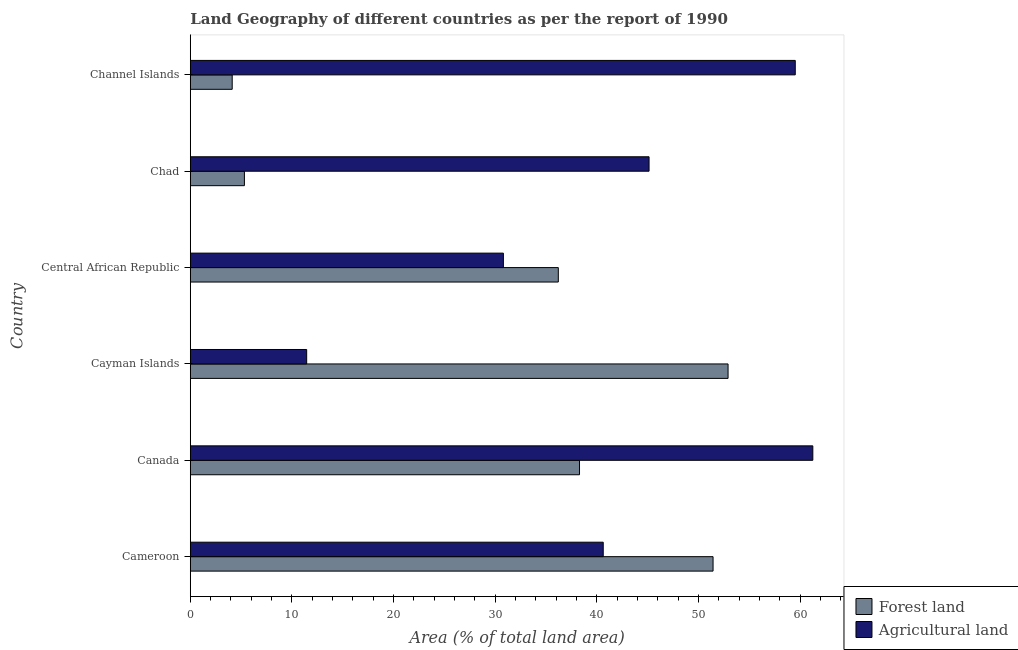How many different coloured bars are there?
Make the answer very short. 2. How many groups of bars are there?
Give a very brief answer. 6. How many bars are there on the 4th tick from the bottom?
Give a very brief answer. 2. What is the label of the 6th group of bars from the top?
Your answer should be compact. Cameroon. In how many cases, is the number of bars for a given country not equal to the number of legend labels?
Your answer should be very brief. 0. What is the percentage of land area under agriculture in Central African Republic?
Keep it short and to the point. 30.81. Across all countries, what is the maximum percentage of land area under agriculture?
Make the answer very short. 61.26. Across all countries, what is the minimum percentage of land area under forests?
Provide a short and direct response. 4.12. In which country was the percentage of land area under agriculture minimum?
Offer a terse response. Cayman Islands. What is the total percentage of land area under agriculture in the graph?
Provide a succinct answer. 248.82. What is the difference between the percentage of land area under forests in Cameroon and that in Central African Republic?
Give a very brief answer. 15.23. What is the difference between the percentage of land area under agriculture in Canada and the percentage of land area under forests in Chad?
Ensure brevity in your answer.  55.93. What is the average percentage of land area under forests per country?
Keep it short and to the point. 31.39. What is the difference between the percentage of land area under agriculture and percentage of land area under forests in Channel Islands?
Give a very brief answer. 55.41. In how many countries, is the percentage of land area under agriculture greater than 28 %?
Your answer should be compact. 5. What is the ratio of the percentage of land area under agriculture in Cameroon to that in Channel Islands?
Ensure brevity in your answer.  0.68. Is the percentage of land area under agriculture in Cameroon less than that in Central African Republic?
Offer a very short reply. No. Is the difference between the percentage of land area under forests in Cameroon and Channel Islands greater than the difference between the percentage of land area under agriculture in Cameroon and Channel Islands?
Make the answer very short. Yes. What is the difference between the highest and the second highest percentage of land area under agriculture?
Your answer should be compact. 1.73. What is the difference between the highest and the lowest percentage of land area under agriculture?
Your answer should be very brief. 49.81. In how many countries, is the percentage of land area under forests greater than the average percentage of land area under forests taken over all countries?
Your answer should be very brief. 4. What does the 2nd bar from the top in Canada represents?
Give a very brief answer. Forest land. What does the 2nd bar from the bottom in Channel Islands represents?
Your response must be concise. Agricultural land. How many bars are there?
Offer a very short reply. 12. How many countries are there in the graph?
Your response must be concise. 6. Where does the legend appear in the graph?
Offer a terse response. Bottom right. What is the title of the graph?
Your answer should be compact. Land Geography of different countries as per the report of 1990. What is the label or title of the X-axis?
Keep it short and to the point. Area (% of total land area). What is the Area (% of total land area) in Forest land in Cameroon?
Your answer should be very brief. 51.44. What is the Area (% of total land area) of Agricultural land in Cameroon?
Offer a very short reply. 40.63. What is the Area (% of total land area) of Forest land in Canada?
Ensure brevity in your answer.  38.3. What is the Area (% of total land area) of Agricultural land in Canada?
Provide a short and direct response. 61.26. What is the Area (% of total land area) of Forest land in Cayman Islands?
Ensure brevity in your answer.  52.92. What is the Area (% of total land area) of Agricultural land in Cayman Islands?
Offer a very short reply. 11.45. What is the Area (% of total land area) in Forest land in Central African Republic?
Offer a terse response. 36.21. What is the Area (% of total land area) in Agricultural land in Central African Republic?
Keep it short and to the point. 30.81. What is the Area (% of total land area) in Forest land in Chad?
Offer a terse response. 5.32. What is the Area (% of total land area) in Agricultural land in Chad?
Make the answer very short. 45.14. What is the Area (% of total land area) in Forest land in Channel Islands?
Give a very brief answer. 4.12. What is the Area (% of total land area) in Agricultural land in Channel Islands?
Ensure brevity in your answer.  59.53. Across all countries, what is the maximum Area (% of total land area) of Forest land?
Keep it short and to the point. 52.92. Across all countries, what is the maximum Area (% of total land area) in Agricultural land?
Offer a terse response. 61.26. Across all countries, what is the minimum Area (% of total land area) in Forest land?
Keep it short and to the point. 4.12. Across all countries, what is the minimum Area (% of total land area) of Agricultural land?
Make the answer very short. 11.45. What is the total Area (% of total land area) of Forest land in the graph?
Your answer should be very brief. 188.32. What is the total Area (% of total land area) in Agricultural land in the graph?
Make the answer very short. 248.82. What is the difference between the Area (% of total land area) in Forest land in Cameroon and that in Canada?
Offer a very short reply. 13.14. What is the difference between the Area (% of total land area) of Agricultural land in Cameroon and that in Canada?
Make the answer very short. -20.62. What is the difference between the Area (% of total land area) in Forest land in Cameroon and that in Cayman Islands?
Make the answer very short. -1.48. What is the difference between the Area (% of total land area) of Agricultural land in Cameroon and that in Cayman Islands?
Provide a succinct answer. 29.18. What is the difference between the Area (% of total land area) of Forest land in Cameroon and that in Central African Republic?
Provide a succinct answer. 15.23. What is the difference between the Area (% of total land area) in Agricultural land in Cameroon and that in Central African Republic?
Provide a short and direct response. 9.83. What is the difference between the Area (% of total land area) in Forest land in Cameroon and that in Chad?
Offer a very short reply. 46.11. What is the difference between the Area (% of total land area) of Agricultural land in Cameroon and that in Chad?
Offer a very short reply. -4.51. What is the difference between the Area (% of total land area) of Forest land in Cameroon and that in Channel Islands?
Your answer should be compact. 47.32. What is the difference between the Area (% of total land area) of Agricultural land in Cameroon and that in Channel Islands?
Keep it short and to the point. -18.89. What is the difference between the Area (% of total land area) in Forest land in Canada and that in Cayman Islands?
Your answer should be compact. -14.62. What is the difference between the Area (% of total land area) of Agricultural land in Canada and that in Cayman Islands?
Your response must be concise. 49.81. What is the difference between the Area (% of total land area) in Forest land in Canada and that in Central African Republic?
Your response must be concise. 2.09. What is the difference between the Area (% of total land area) in Agricultural land in Canada and that in Central African Republic?
Your answer should be very brief. 30.45. What is the difference between the Area (% of total land area) of Forest land in Canada and that in Chad?
Ensure brevity in your answer.  32.97. What is the difference between the Area (% of total land area) of Agricultural land in Canada and that in Chad?
Give a very brief answer. 16.11. What is the difference between the Area (% of total land area) in Forest land in Canada and that in Channel Islands?
Give a very brief answer. 34.18. What is the difference between the Area (% of total land area) in Agricultural land in Canada and that in Channel Islands?
Ensure brevity in your answer.  1.73. What is the difference between the Area (% of total land area) in Forest land in Cayman Islands and that in Central African Republic?
Make the answer very short. 16.7. What is the difference between the Area (% of total land area) in Agricultural land in Cayman Islands and that in Central African Republic?
Provide a succinct answer. -19.36. What is the difference between the Area (% of total land area) of Forest land in Cayman Islands and that in Chad?
Your answer should be compact. 47.59. What is the difference between the Area (% of total land area) in Agricultural land in Cayman Islands and that in Chad?
Provide a succinct answer. -33.69. What is the difference between the Area (% of total land area) of Forest land in Cayman Islands and that in Channel Islands?
Offer a very short reply. 48.79. What is the difference between the Area (% of total land area) of Agricultural land in Cayman Islands and that in Channel Islands?
Provide a succinct answer. -48.08. What is the difference between the Area (% of total land area) of Forest land in Central African Republic and that in Chad?
Provide a short and direct response. 30.89. What is the difference between the Area (% of total land area) of Agricultural land in Central African Republic and that in Chad?
Offer a very short reply. -14.33. What is the difference between the Area (% of total land area) of Forest land in Central African Republic and that in Channel Islands?
Provide a short and direct response. 32.09. What is the difference between the Area (% of total land area) of Agricultural land in Central African Republic and that in Channel Islands?
Offer a terse response. -28.72. What is the difference between the Area (% of total land area) of Forest land in Chad and that in Channel Islands?
Keep it short and to the point. 1.2. What is the difference between the Area (% of total land area) of Agricultural land in Chad and that in Channel Islands?
Give a very brief answer. -14.39. What is the difference between the Area (% of total land area) in Forest land in Cameroon and the Area (% of total land area) in Agricultural land in Canada?
Your answer should be compact. -9.82. What is the difference between the Area (% of total land area) of Forest land in Cameroon and the Area (% of total land area) of Agricultural land in Cayman Islands?
Make the answer very short. 39.99. What is the difference between the Area (% of total land area) in Forest land in Cameroon and the Area (% of total land area) in Agricultural land in Central African Republic?
Your response must be concise. 20.63. What is the difference between the Area (% of total land area) of Forest land in Cameroon and the Area (% of total land area) of Agricultural land in Chad?
Provide a short and direct response. 6.3. What is the difference between the Area (% of total land area) of Forest land in Cameroon and the Area (% of total land area) of Agricultural land in Channel Islands?
Your answer should be compact. -8.09. What is the difference between the Area (% of total land area) of Forest land in Canada and the Area (% of total land area) of Agricultural land in Cayman Islands?
Offer a very short reply. 26.85. What is the difference between the Area (% of total land area) of Forest land in Canada and the Area (% of total land area) of Agricultural land in Central African Republic?
Offer a very short reply. 7.49. What is the difference between the Area (% of total land area) of Forest land in Canada and the Area (% of total land area) of Agricultural land in Chad?
Keep it short and to the point. -6.84. What is the difference between the Area (% of total land area) in Forest land in Canada and the Area (% of total land area) in Agricultural land in Channel Islands?
Provide a short and direct response. -21.23. What is the difference between the Area (% of total land area) of Forest land in Cayman Islands and the Area (% of total land area) of Agricultural land in Central African Republic?
Your answer should be compact. 22.11. What is the difference between the Area (% of total land area) in Forest land in Cayman Islands and the Area (% of total land area) in Agricultural land in Chad?
Your answer should be compact. 7.77. What is the difference between the Area (% of total land area) of Forest land in Cayman Islands and the Area (% of total land area) of Agricultural land in Channel Islands?
Your response must be concise. -6.61. What is the difference between the Area (% of total land area) of Forest land in Central African Republic and the Area (% of total land area) of Agricultural land in Chad?
Keep it short and to the point. -8.93. What is the difference between the Area (% of total land area) of Forest land in Central African Republic and the Area (% of total land area) of Agricultural land in Channel Islands?
Provide a succinct answer. -23.32. What is the difference between the Area (% of total land area) of Forest land in Chad and the Area (% of total land area) of Agricultural land in Channel Islands?
Offer a terse response. -54.2. What is the average Area (% of total land area) of Forest land per country?
Make the answer very short. 31.39. What is the average Area (% of total land area) in Agricultural land per country?
Make the answer very short. 41.47. What is the difference between the Area (% of total land area) in Forest land and Area (% of total land area) in Agricultural land in Cameroon?
Offer a very short reply. 10.81. What is the difference between the Area (% of total land area) in Forest land and Area (% of total land area) in Agricultural land in Canada?
Offer a terse response. -22.96. What is the difference between the Area (% of total land area) in Forest land and Area (% of total land area) in Agricultural land in Cayman Islands?
Offer a very short reply. 41.47. What is the difference between the Area (% of total land area) of Forest land and Area (% of total land area) of Agricultural land in Central African Republic?
Keep it short and to the point. 5.4. What is the difference between the Area (% of total land area) of Forest land and Area (% of total land area) of Agricultural land in Chad?
Offer a terse response. -39.82. What is the difference between the Area (% of total land area) in Forest land and Area (% of total land area) in Agricultural land in Channel Islands?
Ensure brevity in your answer.  -55.4. What is the ratio of the Area (% of total land area) of Forest land in Cameroon to that in Canada?
Make the answer very short. 1.34. What is the ratio of the Area (% of total land area) of Agricultural land in Cameroon to that in Canada?
Keep it short and to the point. 0.66. What is the ratio of the Area (% of total land area) of Forest land in Cameroon to that in Cayman Islands?
Your answer should be compact. 0.97. What is the ratio of the Area (% of total land area) in Agricultural land in Cameroon to that in Cayman Islands?
Keep it short and to the point. 3.55. What is the ratio of the Area (% of total land area) of Forest land in Cameroon to that in Central African Republic?
Provide a short and direct response. 1.42. What is the ratio of the Area (% of total land area) in Agricultural land in Cameroon to that in Central African Republic?
Provide a short and direct response. 1.32. What is the ratio of the Area (% of total land area) of Forest land in Cameroon to that in Chad?
Your answer should be compact. 9.66. What is the ratio of the Area (% of total land area) of Agricultural land in Cameroon to that in Chad?
Your answer should be very brief. 0.9. What is the ratio of the Area (% of total land area) of Forest land in Cameroon to that in Channel Islands?
Provide a short and direct response. 12.47. What is the ratio of the Area (% of total land area) of Agricultural land in Cameroon to that in Channel Islands?
Give a very brief answer. 0.68. What is the ratio of the Area (% of total land area) of Forest land in Canada to that in Cayman Islands?
Ensure brevity in your answer.  0.72. What is the ratio of the Area (% of total land area) of Agricultural land in Canada to that in Cayman Islands?
Your answer should be compact. 5.35. What is the ratio of the Area (% of total land area) of Forest land in Canada to that in Central African Republic?
Ensure brevity in your answer.  1.06. What is the ratio of the Area (% of total land area) of Agricultural land in Canada to that in Central African Republic?
Your answer should be very brief. 1.99. What is the ratio of the Area (% of total land area) of Forest land in Canada to that in Chad?
Make the answer very short. 7.19. What is the ratio of the Area (% of total land area) in Agricultural land in Canada to that in Chad?
Ensure brevity in your answer.  1.36. What is the ratio of the Area (% of total land area) in Forest land in Canada to that in Channel Islands?
Provide a short and direct response. 9.29. What is the ratio of the Area (% of total land area) in Agricultural land in Canada to that in Channel Islands?
Provide a succinct answer. 1.03. What is the ratio of the Area (% of total land area) of Forest land in Cayman Islands to that in Central African Republic?
Your response must be concise. 1.46. What is the ratio of the Area (% of total land area) of Agricultural land in Cayman Islands to that in Central African Republic?
Provide a short and direct response. 0.37. What is the ratio of the Area (% of total land area) of Forest land in Cayman Islands to that in Chad?
Your response must be concise. 9.94. What is the ratio of the Area (% of total land area) in Agricultural land in Cayman Islands to that in Chad?
Ensure brevity in your answer.  0.25. What is the ratio of the Area (% of total land area) of Forest land in Cayman Islands to that in Channel Islands?
Provide a short and direct response. 12.83. What is the ratio of the Area (% of total land area) in Agricultural land in Cayman Islands to that in Channel Islands?
Offer a very short reply. 0.19. What is the ratio of the Area (% of total land area) of Forest land in Central African Republic to that in Chad?
Your answer should be very brief. 6.8. What is the ratio of the Area (% of total land area) of Agricultural land in Central African Republic to that in Chad?
Keep it short and to the point. 0.68. What is the ratio of the Area (% of total land area) in Forest land in Central African Republic to that in Channel Islands?
Keep it short and to the point. 8.78. What is the ratio of the Area (% of total land area) in Agricultural land in Central African Republic to that in Channel Islands?
Ensure brevity in your answer.  0.52. What is the ratio of the Area (% of total land area) of Forest land in Chad to that in Channel Islands?
Give a very brief answer. 1.29. What is the ratio of the Area (% of total land area) in Agricultural land in Chad to that in Channel Islands?
Keep it short and to the point. 0.76. What is the difference between the highest and the second highest Area (% of total land area) in Forest land?
Offer a very short reply. 1.48. What is the difference between the highest and the second highest Area (% of total land area) of Agricultural land?
Offer a terse response. 1.73. What is the difference between the highest and the lowest Area (% of total land area) in Forest land?
Your response must be concise. 48.79. What is the difference between the highest and the lowest Area (% of total land area) in Agricultural land?
Ensure brevity in your answer.  49.81. 